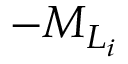<formula> <loc_0><loc_0><loc_500><loc_500>- { M } _ { L _ { i } }</formula> 